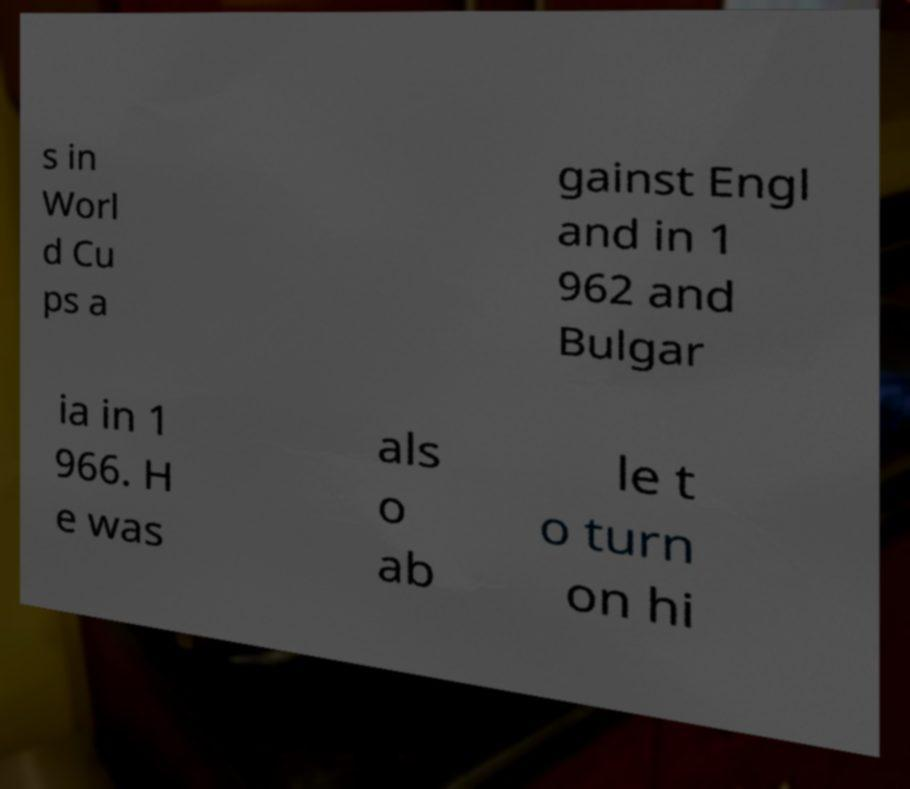Can you accurately transcribe the text from the provided image for me? s in Worl d Cu ps a gainst Engl and in 1 962 and Bulgar ia in 1 966. H e was als o ab le t o turn on hi 